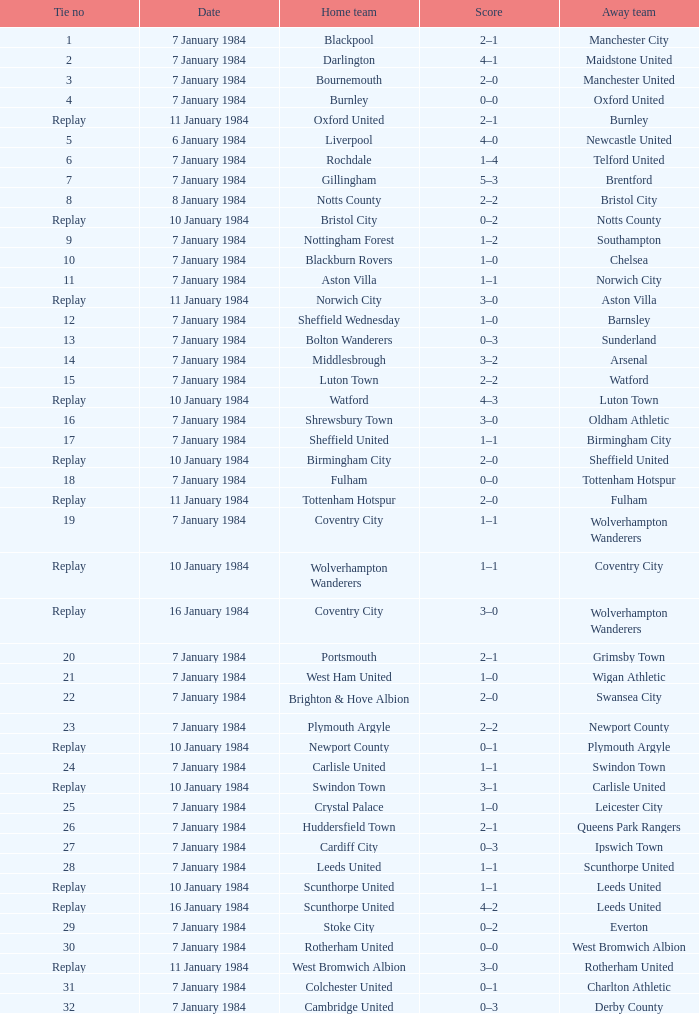Who was the away team against the home team Sheffield United? Birmingham City. Write the full table. {'header': ['Tie no', 'Date', 'Home team', 'Score', 'Away team'], 'rows': [['1', '7 January 1984', 'Blackpool', '2–1', 'Manchester City'], ['2', '7 January 1984', 'Darlington', '4–1', 'Maidstone United'], ['3', '7 January 1984', 'Bournemouth', '2–0', 'Manchester United'], ['4', '7 January 1984', 'Burnley', '0–0', 'Oxford United'], ['Replay', '11 January 1984', 'Oxford United', '2–1', 'Burnley'], ['5', '6 January 1984', 'Liverpool', '4–0', 'Newcastle United'], ['6', '7 January 1984', 'Rochdale', '1–4', 'Telford United'], ['7', '7 January 1984', 'Gillingham', '5–3', 'Brentford'], ['8', '8 January 1984', 'Notts County', '2–2', 'Bristol City'], ['Replay', '10 January 1984', 'Bristol City', '0–2', 'Notts County'], ['9', '7 January 1984', 'Nottingham Forest', '1–2', 'Southampton'], ['10', '7 January 1984', 'Blackburn Rovers', '1–0', 'Chelsea'], ['11', '7 January 1984', 'Aston Villa', '1–1', 'Norwich City'], ['Replay', '11 January 1984', 'Norwich City', '3–0', 'Aston Villa'], ['12', '7 January 1984', 'Sheffield Wednesday', '1–0', 'Barnsley'], ['13', '7 January 1984', 'Bolton Wanderers', '0–3', 'Sunderland'], ['14', '7 January 1984', 'Middlesbrough', '3–2', 'Arsenal'], ['15', '7 January 1984', 'Luton Town', '2–2', 'Watford'], ['Replay', '10 January 1984', 'Watford', '4–3', 'Luton Town'], ['16', '7 January 1984', 'Shrewsbury Town', '3–0', 'Oldham Athletic'], ['17', '7 January 1984', 'Sheffield United', '1–1', 'Birmingham City'], ['Replay', '10 January 1984', 'Birmingham City', '2–0', 'Sheffield United'], ['18', '7 January 1984', 'Fulham', '0–0', 'Tottenham Hotspur'], ['Replay', '11 January 1984', 'Tottenham Hotspur', '2–0', 'Fulham'], ['19', '7 January 1984', 'Coventry City', '1–1', 'Wolverhampton Wanderers'], ['Replay', '10 January 1984', 'Wolverhampton Wanderers', '1–1', 'Coventry City'], ['Replay', '16 January 1984', 'Coventry City', '3–0', 'Wolverhampton Wanderers'], ['20', '7 January 1984', 'Portsmouth', '2–1', 'Grimsby Town'], ['21', '7 January 1984', 'West Ham United', '1–0', 'Wigan Athletic'], ['22', '7 January 1984', 'Brighton & Hove Albion', '2–0', 'Swansea City'], ['23', '7 January 1984', 'Plymouth Argyle', '2–2', 'Newport County'], ['Replay', '10 January 1984', 'Newport County', '0–1', 'Plymouth Argyle'], ['24', '7 January 1984', 'Carlisle United', '1–1', 'Swindon Town'], ['Replay', '10 January 1984', 'Swindon Town', '3–1', 'Carlisle United'], ['25', '7 January 1984', 'Crystal Palace', '1–0', 'Leicester City'], ['26', '7 January 1984', 'Huddersfield Town', '2–1', 'Queens Park Rangers'], ['27', '7 January 1984', 'Cardiff City', '0–3', 'Ipswich Town'], ['28', '7 January 1984', 'Leeds United', '1–1', 'Scunthorpe United'], ['Replay', '10 January 1984', 'Scunthorpe United', '1–1', 'Leeds United'], ['Replay', '16 January 1984', 'Scunthorpe United', '4–2', 'Leeds United'], ['29', '7 January 1984', 'Stoke City', '0–2', 'Everton'], ['30', '7 January 1984', 'Rotherham United', '0–0', 'West Bromwich Albion'], ['Replay', '11 January 1984', 'West Bromwich Albion', '3–0', 'Rotherham United'], ['31', '7 January 1984', 'Colchester United', '0–1', 'Charlton Athletic'], ['32', '7 January 1984', 'Cambridge United', '0–3', 'Derby County']]} 